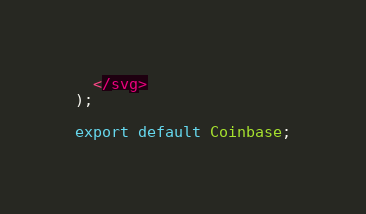<code> <loc_0><loc_0><loc_500><loc_500><_JavaScript_>  </svg>
);

export default Coinbase;
</code> 